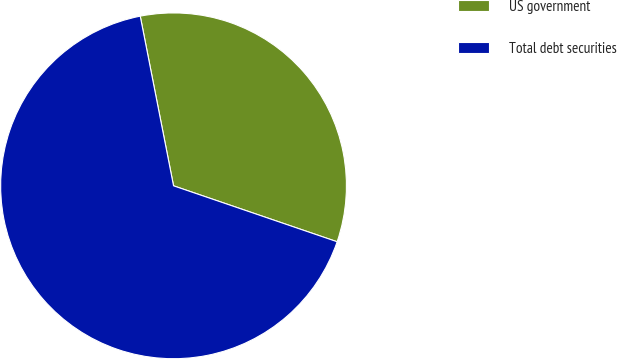Convert chart. <chart><loc_0><loc_0><loc_500><loc_500><pie_chart><fcel>US government<fcel>Total debt securities<nl><fcel>33.33%<fcel>66.67%<nl></chart> 